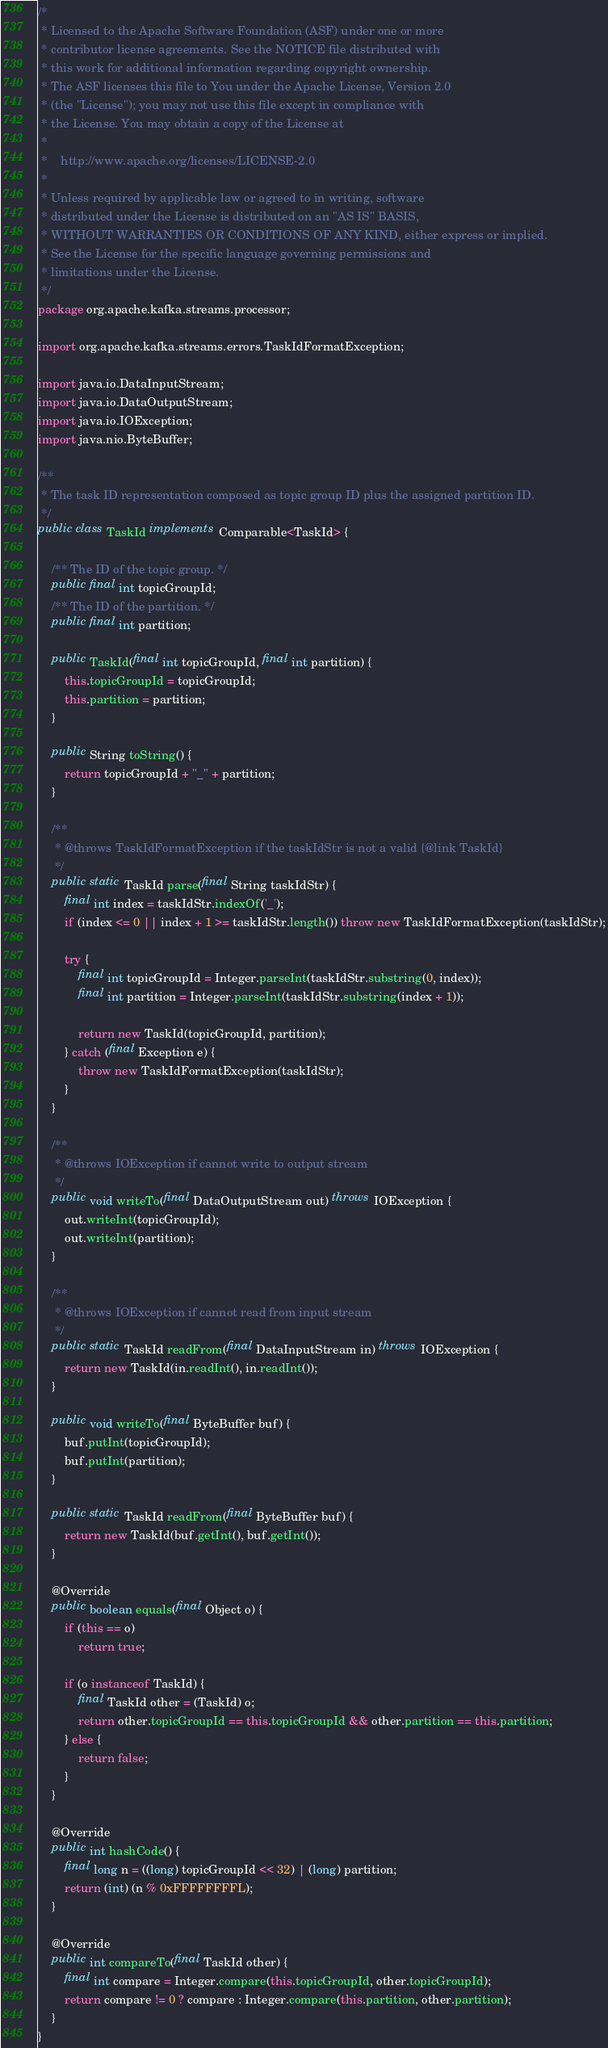Convert code to text. <code><loc_0><loc_0><loc_500><loc_500><_Java_>/*
 * Licensed to the Apache Software Foundation (ASF) under one or more
 * contributor license agreements. See the NOTICE file distributed with
 * this work for additional information regarding copyright ownership.
 * The ASF licenses this file to You under the Apache License, Version 2.0
 * (the "License"); you may not use this file except in compliance with
 * the License. You may obtain a copy of the License at
 *
 *    http://www.apache.org/licenses/LICENSE-2.0
 *
 * Unless required by applicable law or agreed to in writing, software
 * distributed under the License is distributed on an "AS IS" BASIS,
 * WITHOUT WARRANTIES OR CONDITIONS OF ANY KIND, either express or implied.
 * See the License for the specific language governing permissions and
 * limitations under the License.
 */
package org.apache.kafka.streams.processor;

import org.apache.kafka.streams.errors.TaskIdFormatException;

import java.io.DataInputStream;
import java.io.DataOutputStream;
import java.io.IOException;
import java.nio.ByteBuffer;

/**
 * The task ID representation composed as topic group ID plus the assigned partition ID.
 */
public class TaskId implements Comparable<TaskId> {

    /** The ID of the topic group. */
    public final int topicGroupId;
    /** The ID of the partition. */
    public final int partition;

    public TaskId(final int topicGroupId, final int partition) {
        this.topicGroupId = topicGroupId;
        this.partition = partition;
    }

    public String toString() {
        return topicGroupId + "_" + partition;
    }

    /**
     * @throws TaskIdFormatException if the taskIdStr is not a valid {@link TaskId}
     */
    public static TaskId parse(final String taskIdStr) {
        final int index = taskIdStr.indexOf('_');
        if (index <= 0 || index + 1 >= taskIdStr.length()) throw new TaskIdFormatException(taskIdStr);

        try {
            final int topicGroupId = Integer.parseInt(taskIdStr.substring(0, index));
            final int partition = Integer.parseInt(taskIdStr.substring(index + 1));

            return new TaskId(topicGroupId, partition);
        } catch (final Exception e) {
            throw new TaskIdFormatException(taskIdStr);
        }
    }

    /**
     * @throws IOException if cannot write to output stream
     */
    public void writeTo(final DataOutputStream out) throws IOException {
        out.writeInt(topicGroupId);
        out.writeInt(partition);
    }

    /**
     * @throws IOException if cannot read from input stream
     */
    public static TaskId readFrom(final DataInputStream in) throws IOException {
        return new TaskId(in.readInt(), in.readInt());
    }

    public void writeTo(final ByteBuffer buf) {
        buf.putInt(topicGroupId);
        buf.putInt(partition);
    }

    public static TaskId readFrom(final ByteBuffer buf) {
        return new TaskId(buf.getInt(), buf.getInt());
    }

    @Override
    public boolean equals(final Object o) {
        if (this == o)
            return true;

        if (o instanceof TaskId) {
            final TaskId other = (TaskId) o;
            return other.topicGroupId == this.topicGroupId && other.partition == this.partition;
        } else {
            return false;
        }
    }

    @Override
    public int hashCode() {
        final long n = ((long) topicGroupId << 32) | (long) partition;
        return (int) (n % 0xFFFFFFFFL);
    }

    @Override
    public int compareTo(final TaskId other) {
        final int compare = Integer.compare(this.topicGroupId, other.topicGroupId);
        return compare != 0 ? compare : Integer.compare(this.partition, other.partition);
    }
}
</code> 